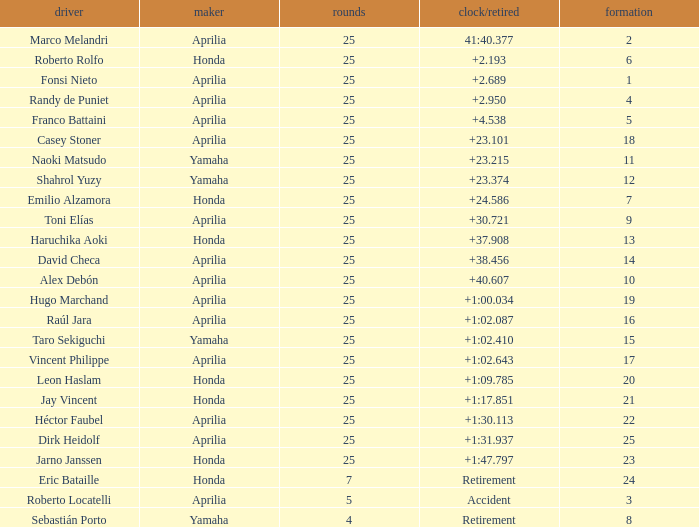Which Laps have a Time/Retired of +23.215, and a Grid larger than 11? None. 